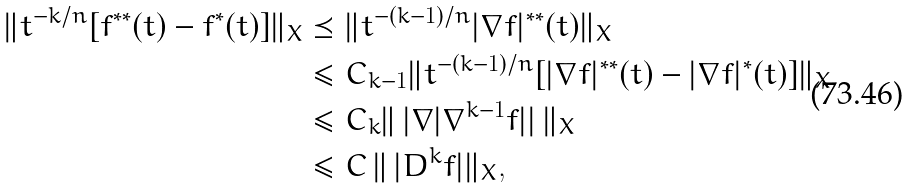Convert formula to latex. <formula><loc_0><loc_0><loc_500><loc_500>\| t ^ { - k / n } [ f ^ { \ast \ast } ( t ) - f ^ { \ast } ( t ) ] \| _ { X } & \preceq \| t ^ { - ( k - 1 ) / n } | \nabla f | ^ { \ast \ast } ( t ) \| _ { X } \\ & \leq C _ { k - 1 } \| t ^ { - ( k - 1 ) / n } [ | \nabla f | ^ { \ast \ast } ( t ) - | \nabla f | ^ { \ast } ( t ) ] \| _ { X } \\ & \leq C _ { k } \| \, | \nabla | \nabla ^ { k - 1 } f | | \, \| _ { X } \\ & \leq C \, \| \, | D ^ { k } f | \| _ { X } ,</formula> 